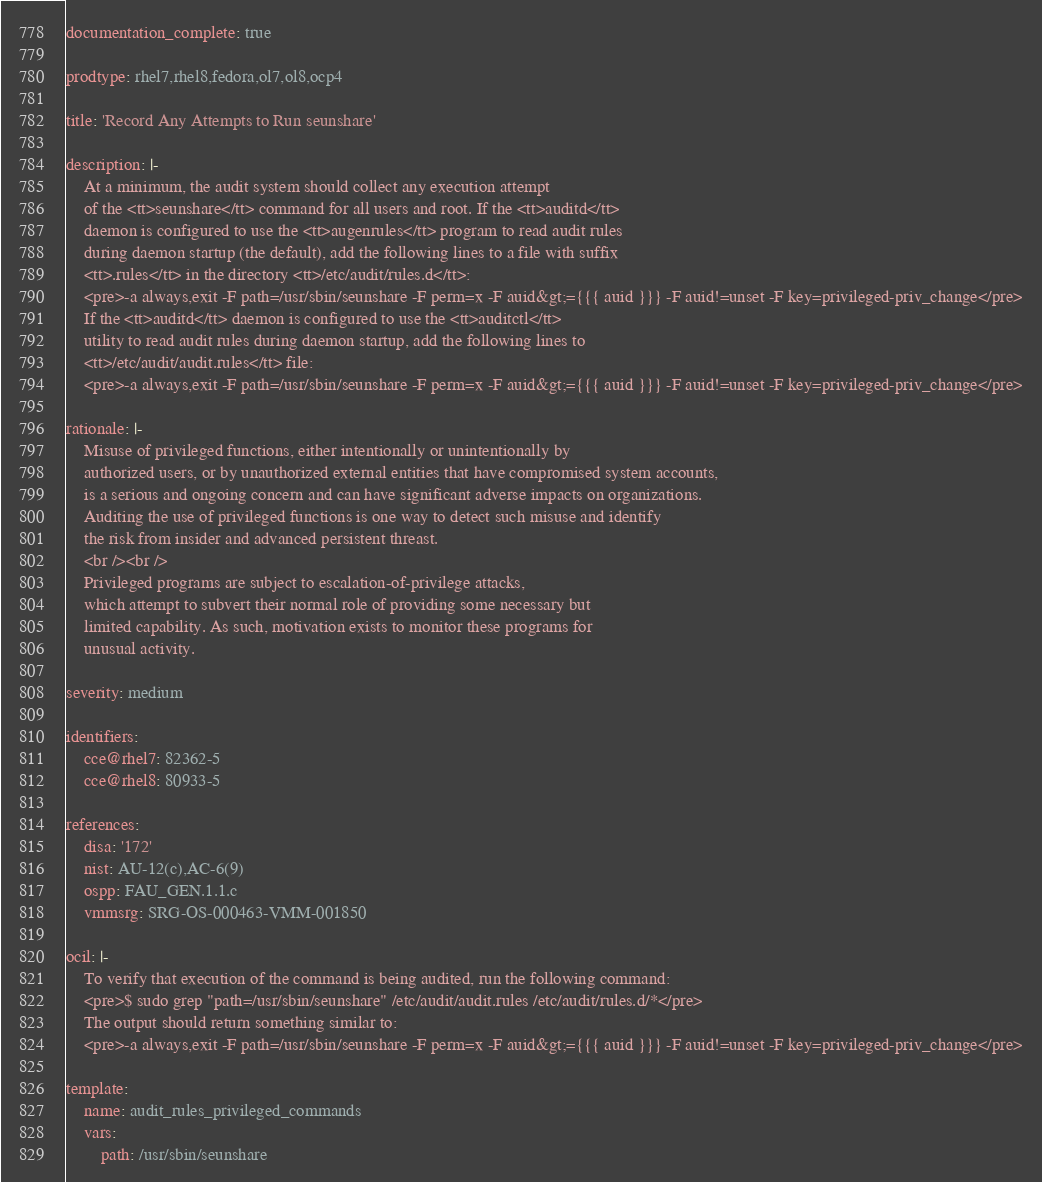Convert code to text. <code><loc_0><loc_0><loc_500><loc_500><_YAML_>documentation_complete: true

prodtype: rhel7,rhel8,fedora,ol7,ol8,ocp4

title: 'Record Any Attempts to Run seunshare'

description: |-
    At a minimum, the audit system should collect any execution attempt
    of the <tt>seunshare</tt> command for all users and root. If the <tt>auditd</tt>
    daemon is configured to use the <tt>augenrules</tt> program to read audit rules
    during daemon startup (the default), add the following lines to a file with suffix
    <tt>.rules</tt> in the directory <tt>/etc/audit/rules.d</tt>:
    <pre>-a always,exit -F path=/usr/sbin/seunshare -F perm=x -F auid&gt;={{{ auid }}} -F auid!=unset -F key=privileged-priv_change</pre>
    If the <tt>auditd</tt> daemon is configured to use the <tt>auditctl</tt>
    utility to read audit rules during daemon startup, add the following lines to
    <tt>/etc/audit/audit.rules</tt> file:
    <pre>-a always,exit -F path=/usr/sbin/seunshare -F perm=x -F auid&gt;={{{ auid }}} -F auid!=unset -F key=privileged-priv_change</pre>

rationale: |-
    Misuse of privileged functions, either intentionally or unintentionally by
    authorized users, or by unauthorized external entities that have compromised system accounts,
    is a serious and ongoing concern and can have significant adverse impacts on organizations.
    Auditing the use of privileged functions is one way to detect such misuse and identify
    the risk from insider and advanced persistent threast.
    <br /><br />
    Privileged programs are subject to escalation-of-privilege attacks,
    which attempt to subvert their normal role of providing some necessary but
    limited capability. As such, motivation exists to monitor these programs for
    unusual activity.

severity: medium

identifiers:
    cce@rhel7: 82362-5
    cce@rhel8: 80933-5

references:
    disa: '172'
    nist: AU-12(c),AC-6(9)
    ospp: FAU_GEN.1.1.c
    vmmsrg: SRG-OS-000463-VMM-001850

ocil: |-
    To verify that execution of the command is being audited, run the following command:
    <pre>$ sudo grep "path=/usr/sbin/seunshare" /etc/audit/audit.rules /etc/audit/rules.d/*</pre>
    The output should return something similar to:
    <pre>-a always,exit -F path=/usr/sbin/seunshare -F perm=x -F auid&gt;={{{ auid }}} -F auid!=unset -F key=privileged-priv_change</pre>

template:
    name: audit_rules_privileged_commands
    vars:
        path: /usr/sbin/seunshare
</code> 